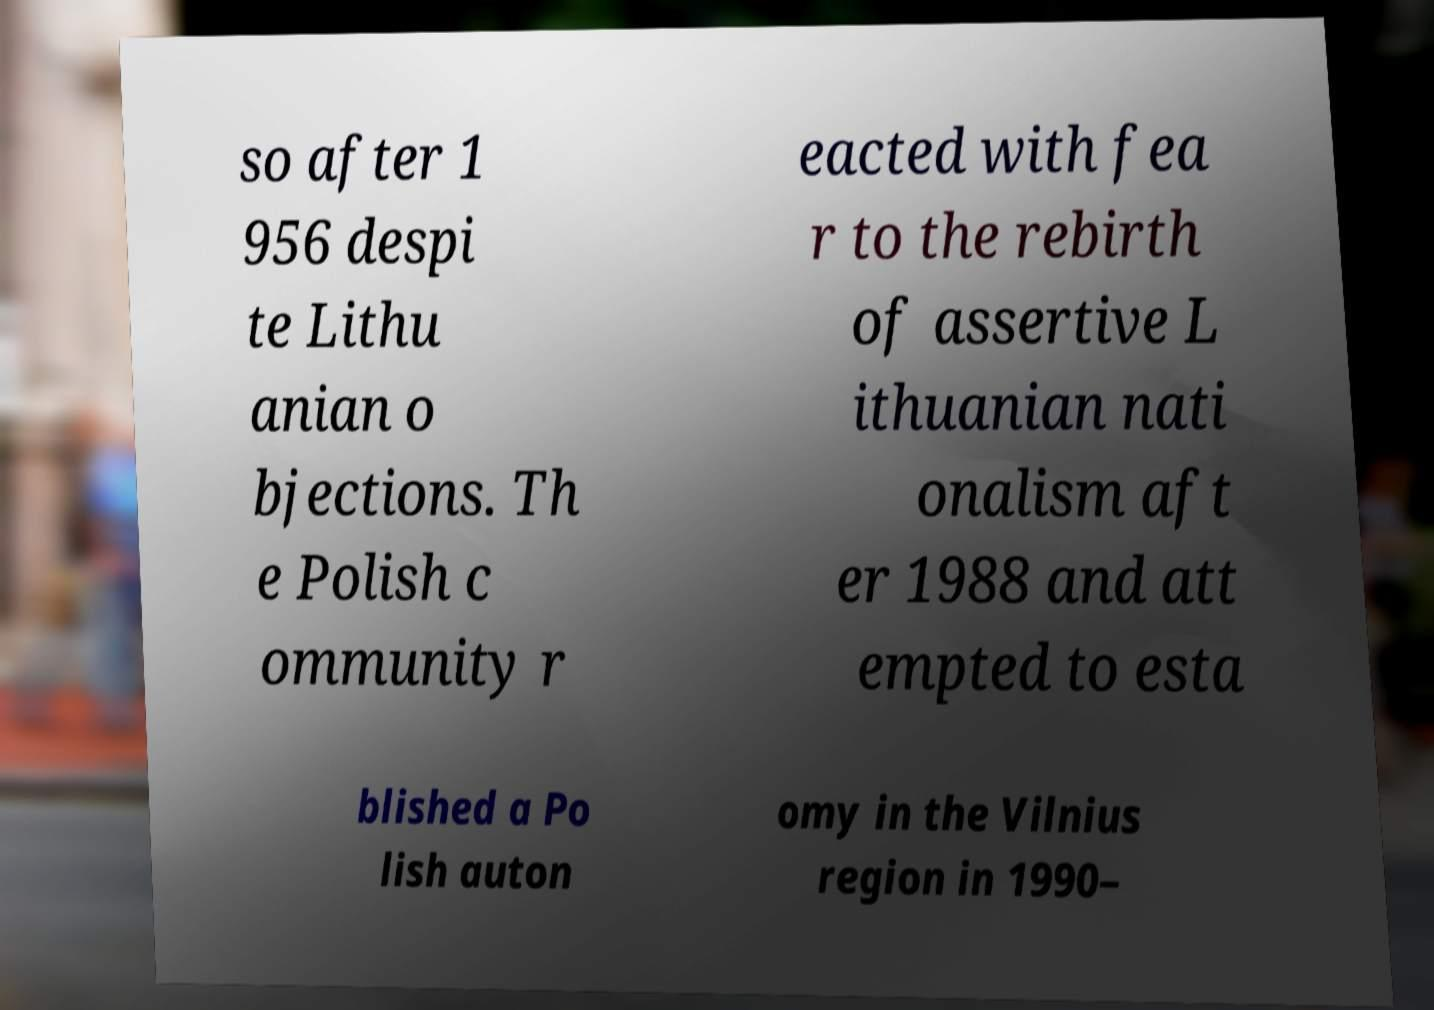Please identify and transcribe the text found in this image. so after 1 956 despi te Lithu anian o bjections. Th e Polish c ommunity r eacted with fea r to the rebirth of assertive L ithuanian nati onalism aft er 1988 and att empted to esta blished a Po lish auton omy in the Vilnius region in 1990– 